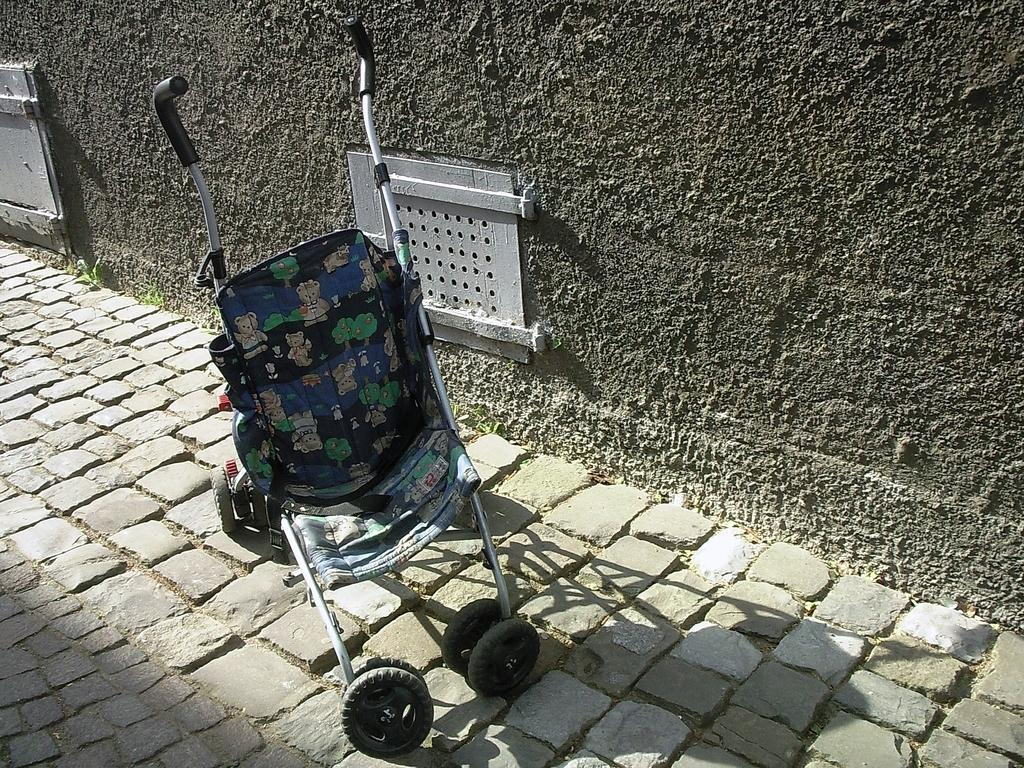What type of furniture is present in the image? There is a baby chair in the image. Where is the baby chair located? The baby chair is kept on the floor. What can be seen in the background of the image? There is a wall visible in the image. What type of train can be seen passing by in the image? There is no train present in the image; it only features a baby chair on the floor and a wall in the background. 